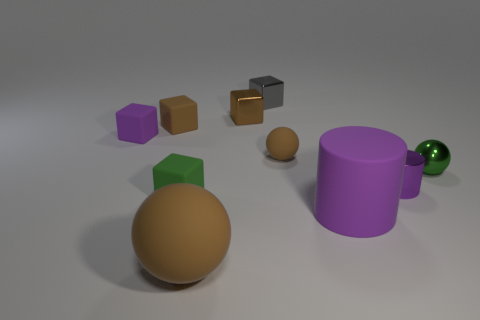Are there any other things that are made of the same material as the large brown ball?
Keep it short and to the point. Yes. There is a matte cylinder; is it the same color as the matte sphere behind the green shiny thing?
Ensure brevity in your answer.  No. Is there a tiny metallic thing that is behind the rubber thing that is left of the small brown matte object that is to the left of the gray shiny thing?
Provide a short and direct response. Yes. Is the number of large brown objects on the right side of the metallic cylinder less than the number of large green rubber objects?
Offer a very short reply. No. What number of other objects are the same shape as the large purple thing?
Offer a terse response. 1. How many objects are either small spheres right of the large cylinder or small cubes that are to the left of the large brown thing?
Offer a very short reply. 4. There is a ball that is on the left side of the large purple matte object and behind the large purple thing; how big is it?
Give a very brief answer. Small. There is a purple rubber object to the left of the small brown rubber block; is it the same shape as the green rubber object?
Offer a very short reply. Yes. What size is the brown rubber object to the right of the brown object behind the tiny brown matte block on the left side of the large purple thing?
Make the answer very short. Small. There is a rubber block that is the same color as the large rubber ball; what size is it?
Your answer should be compact. Small. 